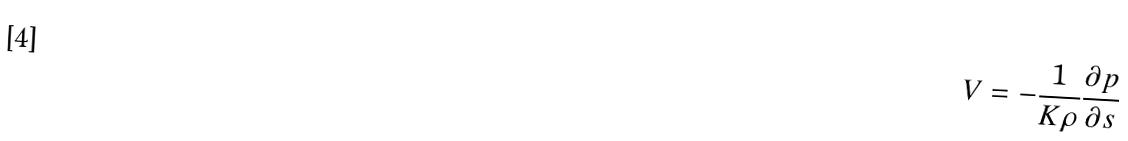<formula> <loc_0><loc_0><loc_500><loc_500>V = - \frac { 1 } { K \rho } \frac { \partial p } { \partial s }</formula> 